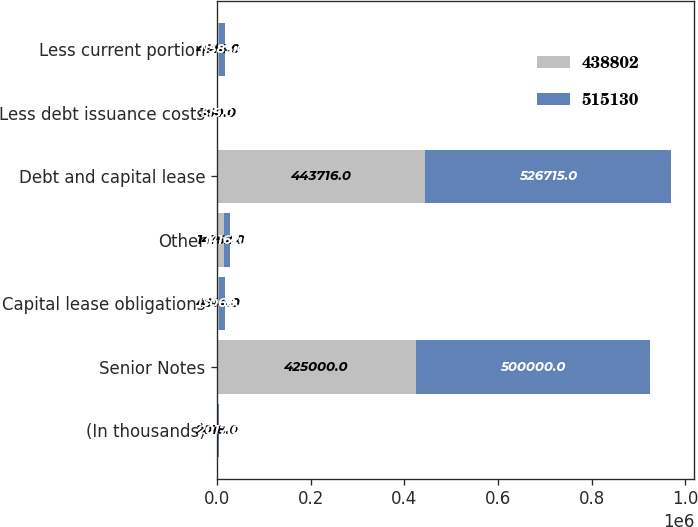Convert chart to OTSL. <chart><loc_0><loc_0><loc_500><loc_500><stacked_bar_chart><ecel><fcel>(In thousands)<fcel>Senior Notes<fcel>Capital lease obligations<fcel>Other<fcel>Debt and capital lease<fcel>Less debt issuance costs<fcel>Less current portion<nl><fcel>438802<fcel>2018<fcel>425000<fcel>4914<fcel>14162<fcel>443716<fcel>360<fcel>4914<nl><fcel>515130<fcel>2017<fcel>500000<fcel>13068<fcel>14162<fcel>526715<fcel>515<fcel>11585<nl></chart> 